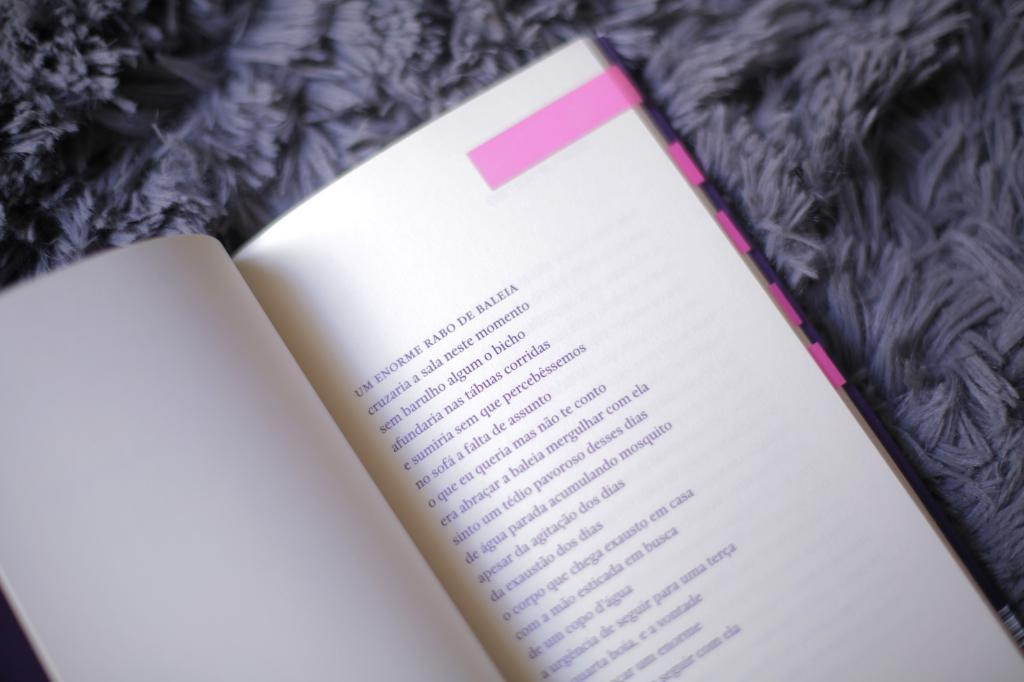<image>
Provide a brief description of the given image. The page of a book is marked with a pink marker and begins with the words Um Emorme Rabo De Baleia. 